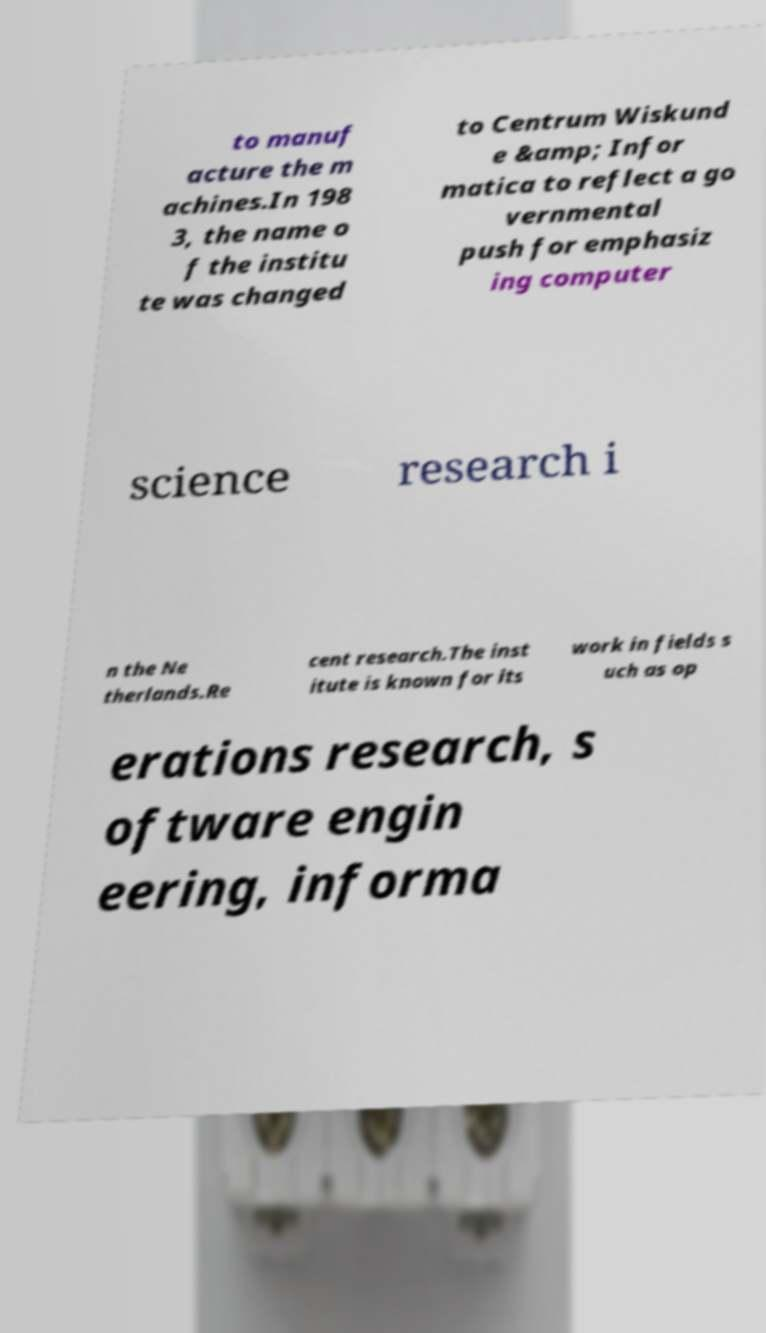What messages or text are displayed in this image? I need them in a readable, typed format. to manuf acture the m achines.In 198 3, the name o f the institu te was changed to Centrum Wiskund e &amp; Infor matica to reflect a go vernmental push for emphasiz ing computer science research i n the Ne therlands.Re cent research.The inst itute is known for its work in fields s uch as op erations research, s oftware engin eering, informa 